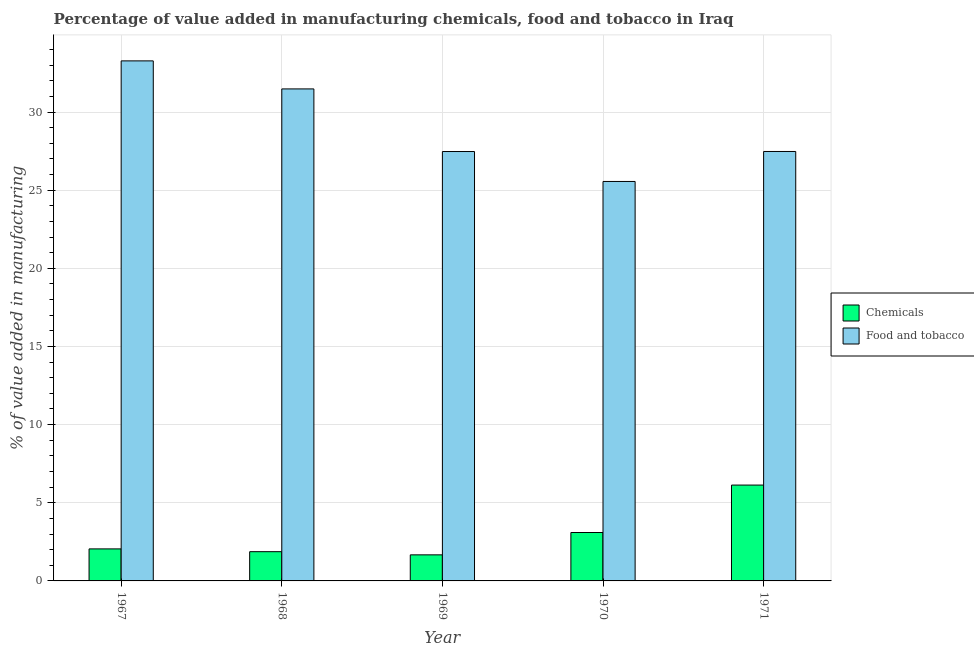How many different coloured bars are there?
Provide a succinct answer. 2. How many bars are there on the 1st tick from the left?
Ensure brevity in your answer.  2. What is the label of the 2nd group of bars from the left?
Provide a succinct answer. 1968. What is the value added by  manufacturing chemicals in 1968?
Keep it short and to the point. 1.87. Across all years, what is the maximum value added by manufacturing food and tobacco?
Provide a short and direct response. 33.27. Across all years, what is the minimum value added by manufacturing food and tobacco?
Offer a terse response. 25.56. In which year was the value added by manufacturing food and tobacco minimum?
Make the answer very short. 1970. What is the total value added by manufacturing food and tobacco in the graph?
Provide a short and direct response. 145.26. What is the difference between the value added by  manufacturing chemicals in 1968 and that in 1970?
Your answer should be compact. -1.23. What is the difference between the value added by manufacturing food and tobacco in 1968 and the value added by  manufacturing chemicals in 1970?
Offer a terse response. 5.92. What is the average value added by manufacturing food and tobacco per year?
Your answer should be very brief. 29.05. In the year 1968, what is the difference between the value added by  manufacturing chemicals and value added by manufacturing food and tobacco?
Give a very brief answer. 0. What is the ratio of the value added by manufacturing food and tobacco in 1967 to that in 1968?
Offer a terse response. 1.06. Is the value added by  manufacturing chemicals in 1967 less than that in 1969?
Provide a short and direct response. No. What is the difference between the highest and the second highest value added by manufacturing food and tobacco?
Offer a terse response. 1.79. What is the difference between the highest and the lowest value added by manufacturing food and tobacco?
Ensure brevity in your answer.  7.72. In how many years, is the value added by  manufacturing chemicals greater than the average value added by  manufacturing chemicals taken over all years?
Make the answer very short. 2. Is the sum of the value added by manufacturing food and tobacco in 1968 and 1970 greater than the maximum value added by  manufacturing chemicals across all years?
Give a very brief answer. Yes. What does the 1st bar from the left in 1971 represents?
Offer a very short reply. Chemicals. What does the 1st bar from the right in 1969 represents?
Your answer should be compact. Food and tobacco. What is the difference between two consecutive major ticks on the Y-axis?
Offer a very short reply. 5. Does the graph contain any zero values?
Provide a succinct answer. No. How are the legend labels stacked?
Provide a succinct answer. Vertical. What is the title of the graph?
Your response must be concise. Percentage of value added in manufacturing chemicals, food and tobacco in Iraq. Does "Rural" appear as one of the legend labels in the graph?
Provide a short and direct response. No. What is the label or title of the Y-axis?
Make the answer very short. % of value added in manufacturing. What is the % of value added in manufacturing in Chemicals in 1967?
Make the answer very short. 2.05. What is the % of value added in manufacturing of Food and tobacco in 1967?
Ensure brevity in your answer.  33.27. What is the % of value added in manufacturing in Chemicals in 1968?
Your response must be concise. 1.87. What is the % of value added in manufacturing of Food and tobacco in 1968?
Give a very brief answer. 31.48. What is the % of value added in manufacturing of Chemicals in 1969?
Provide a succinct answer. 1.67. What is the % of value added in manufacturing in Food and tobacco in 1969?
Provide a short and direct response. 27.47. What is the % of value added in manufacturing of Chemicals in 1970?
Your answer should be compact. 3.1. What is the % of value added in manufacturing in Food and tobacco in 1970?
Make the answer very short. 25.56. What is the % of value added in manufacturing in Chemicals in 1971?
Your response must be concise. 6.13. What is the % of value added in manufacturing in Food and tobacco in 1971?
Offer a very short reply. 27.48. Across all years, what is the maximum % of value added in manufacturing of Chemicals?
Ensure brevity in your answer.  6.13. Across all years, what is the maximum % of value added in manufacturing of Food and tobacco?
Keep it short and to the point. 33.27. Across all years, what is the minimum % of value added in manufacturing in Chemicals?
Keep it short and to the point. 1.67. Across all years, what is the minimum % of value added in manufacturing of Food and tobacco?
Provide a succinct answer. 25.56. What is the total % of value added in manufacturing in Chemicals in the graph?
Offer a very short reply. 14.82. What is the total % of value added in manufacturing of Food and tobacco in the graph?
Your response must be concise. 145.26. What is the difference between the % of value added in manufacturing in Chemicals in 1967 and that in 1968?
Offer a terse response. 0.18. What is the difference between the % of value added in manufacturing of Food and tobacco in 1967 and that in 1968?
Provide a succinct answer. 1.79. What is the difference between the % of value added in manufacturing in Chemicals in 1967 and that in 1969?
Offer a very short reply. 0.38. What is the difference between the % of value added in manufacturing of Food and tobacco in 1967 and that in 1969?
Give a very brief answer. 5.8. What is the difference between the % of value added in manufacturing in Chemicals in 1967 and that in 1970?
Provide a short and direct response. -1.05. What is the difference between the % of value added in manufacturing in Food and tobacco in 1967 and that in 1970?
Make the answer very short. 7.72. What is the difference between the % of value added in manufacturing of Chemicals in 1967 and that in 1971?
Keep it short and to the point. -4.08. What is the difference between the % of value added in manufacturing in Food and tobacco in 1967 and that in 1971?
Your response must be concise. 5.8. What is the difference between the % of value added in manufacturing of Chemicals in 1968 and that in 1969?
Your answer should be compact. 0.2. What is the difference between the % of value added in manufacturing in Food and tobacco in 1968 and that in 1969?
Your answer should be compact. 4.01. What is the difference between the % of value added in manufacturing in Chemicals in 1968 and that in 1970?
Your answer should be very brief. -1.23. What is the difference between the % of value added in manufacturing in Food and tobacco in 1968 and that in 1970?
Your response must be concise. 5.92. What is the difference between the % of value added in manufacturing in Chemicals in 1968 and that in 1971?
Offer a terse response. -4.26. What is the difference between the % of value added in manufacturing of Food and tobacco in 1968 and that in 1971?
Give a very brief answer. 4. What is the difference between the % of value added in manufacturing in Chemicals in 1969 and that in 1970?
Your answer should be very brief. -1.43. What is the difference between the % of value added in manufacturing of Food and tobacco in 1969 and that in 1970?
Your answer should be compact. 1.92. What is the difference between the % of value added in manufacturing in Chemicals in 1969 and that in 1971?
Give a very brief answer. -4.46. What is the difference between the % of value added in manufacturing of Food and tobacco in 1969 and that in 1971?
Provide a succinct answer. -0. What is the difference between the % of value added in manufacturing in Chemicals in 1970 and that in 1971?
Make the answer very short. -3.03. What is the difference between the % of value added in manufacturing in Food and tobacco in 1970 and that in 1971?
Make the answer very short. -1.92. What is the difference between the % of value added in manufacturing in Chemicals in 1967 and the % of value added in manufacturing in Food and tobacco in 1968?
Offer a terse response. -29.43. What is the difference between the % of value added in manufacturing in Chemicals in 1967 and the % of value added in manufacturing in Food and tobacco in 1969?
Your answer should be compact. -25.43. What is the difference between the % of value added in manufacturing of Chemicals in 1967 and the % of value added in manufacturing of Food and tobacco in 1970?
Offer a terse response. -23.51. What is the difference between the % of value added in manufacturing of Chemicals in 1967 and the % of value added in manufacturing of Food and tobacco in 1971?
Provide a succinct answer. -25.43. What is the difference between the % of value added in manufacturing of Chemicals in 1968 and the % of value added in manufacturing of Food and tobacco in 1969?
Ensure brevity in your answer.  -25.6. What is the difference between the % of value added in manufacturing in Chemicals in 1968 and the % of value added in manufacturing in Food and tobacco in 1970?
Your answer should be very brief. -23.69. What is the difference between the % of value added in manufacturing of Chemicals in 1968 and the % of value added in manufacturing of Food and tobacco in 1971?
Give a very brief answer. -25.61. What is the difference between the % of value added in manufacturing of Chemicals in 1969 and the % of value added in manufacturing of Food and tobacco in 1970?
Provide a succinct answer. -23.89. What is the difference between the % of value added in manufacturing in Chemicals in 1969 and the % of value added in manufacturing in Food and tobacco in 1971?
Give a very brief answer. -25.81. What is the difference between the % of value added in manufacturing of Chemicals in 1970 and the % of value added in manufacturing of Food and tobacco in 1971?
Give a very brief answer. -24.38. What is the average % of value added in manufacturing in Chemicals per year?
Provide a succinct answer. 2.96. What is the average % of value added in manufacturing in Food and tobacco per year?
Provide a succinct answer. 29.05. In the year 1967, what is the difference between the % of value added in manufacturing in Chemicals and % of value added in manufacturing in Food and tobacco?
Offer a terse response. -31.22. In the year 1968, what is the difference between the % of value added in manufacturing of Chemicals and % of value added in manufacturing of Food and tobacco?
Provide a succinct answer. -29.61. In the year 1969, what is the difference between the % of value added in manufacturing of Chemicals and % of value added in manufacturing of Food and tobacco?
Keep it short and to the point. -25.81. In the year 1970, what is the difference between the % of value added in manufacturing in Chemicals and % of value added in manufacturing in Food and tobacco?
Offer a terse response. -22.46. In the year 1971, what is the difference between the % of value added in manufacturing in Chemicals and % of value added in manufacturing in Food and tobacco?
Provide a succinct answer. -21.34. What is the ratio of the % of value added in manufacturing of Chemicals in 1967 to that in 1968?
Offer a very short reply. 1.09. What is the ratio of the % of value added in manufacturing in Food and tobacco in 1967 to that in 1968?
Offer a terse response. 1.06. What is the ratio of the % of value added in manufacturing of Chemicals in 1967 to that in 1969?
Offer a terse response. 1.23. What is the ratio of the % of value added in manufacturing of Food and tobacco in 1967 to that in 1969?
Make the answer very short. 1.21. What is the ratio of the % of value added in manufacturing of Chemicals in 1967 to that in 1970?
Keep it short and to the point. 0.66. What is the ratio of the % of value added in manufacturing of Food and tobacco in 1967 to that in 1970?
Keep it short and to the point. 1.3. What is the ratio of the % of value added in manufacturing of Chemicals in 1967 to that in 1971?
Ensure brevity in your answer.  0.33. What is the ratio of the % of value added in manufacturing of Food and tobacco in 1967 to that in 1971?
Provide a short and direct response. 1.21. What is the ratio of the % of value added in manufacturing of Chemicals in 1968 to that in 1969?
Your answer should be very brief. 1.12. What is the ratio of the % of value added in manufacturing in Food and tobacco in 1968 to that in 1969?
Keep it short and to the point. 1.15. What is the ratio of the % of value added in manufacturing of Chemicals in 1968 to that in 1970?
Provide a succinct answer. 0.6. What is the ratio of the % of value added in manufacturing of Food and tobacco in 1968 to that in 1970?
Your response must be concise. 1.23. What is the ratio of the % of value added in manufacturing in Chemicals in 1968 to that in 1971?
Your answer should be very brief. 0.31. What is the ratio of the % of value added in manufacturing in Food and tobacco in 1968 to that in 1971?
Provide a short and direct response. 1.15. What is the ratio of the % of value added in manufacturing in Chemicals in 1969 to that in 1970?
Offer a very short reply. 0.54. What is the ratio of the % of value added in manufacturing of Food and tobacco in 1969 to that in 1970?
Make the answer very short. 1.07. What is the ratio of the % of value added in manufacturing of Chemicals in 1969 to that in 1971?
Keep it short and to the point. 0.27. What is the ratio of the % of value added in manufacturing in Food and tobacco in 1969 to that in 1971?
Give a very brief answer. 1. What is the ratio of the % of value added in manufacturing of Chemicals in 1970 to that in 1971?
Give a very brief answer. 0.51. What is the ratio of the % of value added in manufacturing of Food and tobacco in 1970 to that in 1971?
Provide a short and direct response. 0.93. What is the difference between the highest and the second highest % of value added in manufacturing in Chemicals?
Keep it short and to the point. 3.03. What is the difference between the highest and the second highest % of value added in manufacturing in Food and tobacco?
Your answer should be compact. 1.79. What is the difference between the highest and the lowest % of value added in manufacturing of Chemicals?
Make the answer very short. 4.46. What is the difference between the highest and the lowest % of value added in manufacturing of Food and tobacco?
Ensure brevity in your answer.  7.72. 